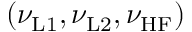Convert formula to latex. <formula><loc_0><loc_0><loc_500><loc_500>( \nu _ { L 1 } , \nu _ { L 2 } , \nu _ { H F } )</formula> 